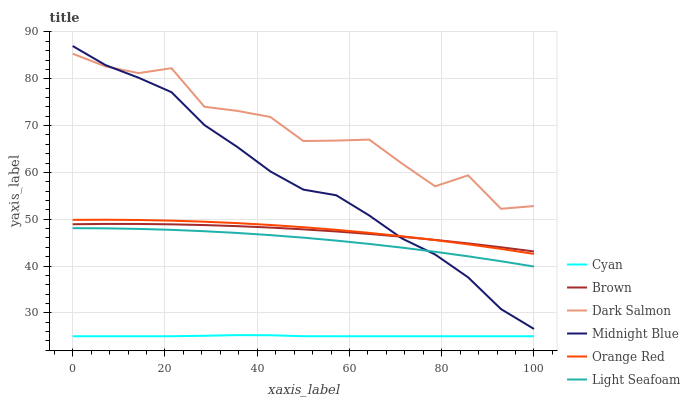Does Cyan have the minimum area under the curve?
Answer yes or no. Yes. Does Dark Salmon have the maximum area under the curve?
Answer yes or no. Yes. Does Midnight Blue have the minimum area under the curve?
Answer yes or no. No. Does Midnight Blue have the maximum area under the curve?
Answer yes or no. No. Is Cyan the smoothest?
Answer yes or no. Yes. Is Dark Salmon the roughest?
Answer yes or no. Yes. Is Midnight Blue the smoothest?
Answer yes or no. No. Is Midnight Blue the roughest?
Answer yes or no. No. Does Cyan have the lowest value?
Answer yes or no. Yes. Does Midnight Blue have the lowest value?
Answer yes or no. No. Does Midnight Blue have the highest value?
Answer yes or no. Yes. Does Dark Salmon have the highest value?
Answer yes or no. No. Is Cyan less than Dark Salmon?
Answer yes or no. Yes. Is Orange Red greater than Cyan?
Answer yes or no. Yes. Does Brown intersect Midnight Blue?
Answer yes or no. Yes. Is Brown less than Midnight Blue?
Answer yes or no. No. Is Brown greater than Midnight Blue?
Answer yes or no. No. Does Cyan intersect Dark Salmon?
Answer yes or no. No. 